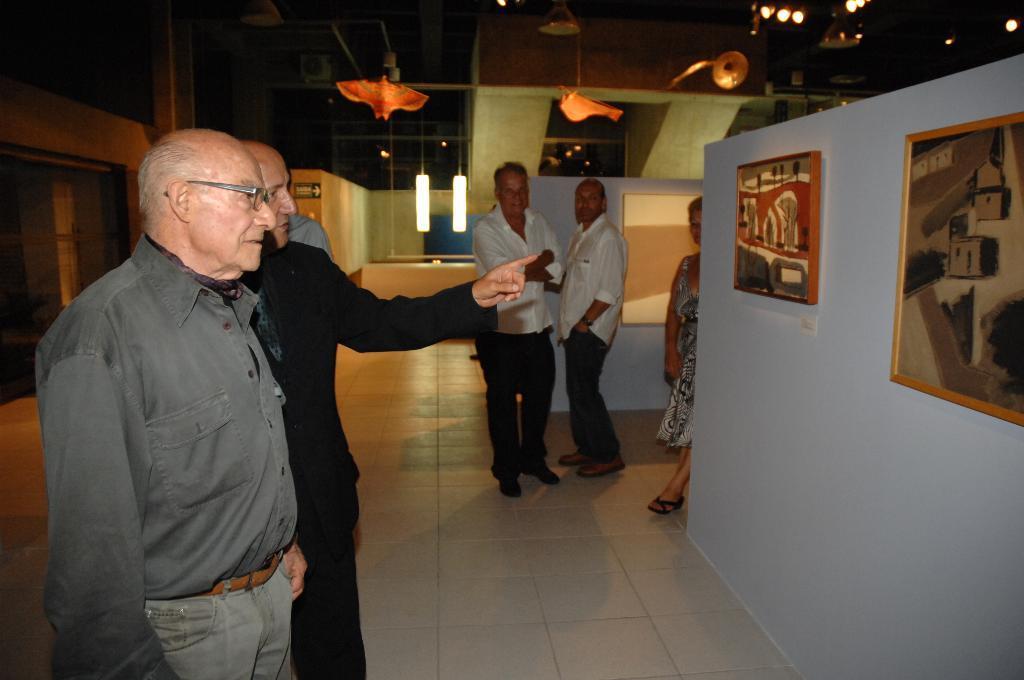In one or two sentences, can you explain what this image depicts? In this image there are a few people standing and watching art inside an art gallery, in the background of the image there are lamps. 